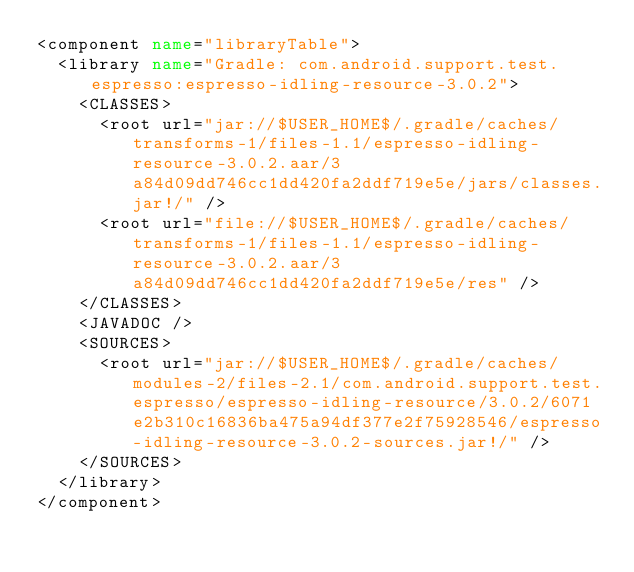Convert code to text. <code><loc_0><loc_0><loc_500><loc_500><_XML_><component name="libraryTable">
  <library name="Gradle: com.android.support.test.espresso:espresso-idling-resource-3.0.2">
    <CLASSES>
      <root url="jar://$USER_HOME$/.gradle/caches/transforms-1/files-1.1/espresso-idling-resource-3.0.2.aar/3a84d09dd746cc1dd420fa2ddf719e5e/jars/classes.jar!/" />
      <root url="file://$USER_HOME$/.gradle/caches/transforms-1/files-1.1/espresso-idling-resource-3.0.2.aar/3a84d09dd746cc1dd420fa2ddf719e5e/res" />
    </CLASSES>
    <JAVADOC />
    <SOURCES>
      <root url="jar://$USER_HOME$/.gradle/caches/modules-2/files-2.1/com.android.support.test.espresso/espresso-idling-resource/3.0.2/6071e2b310c16836ba475a94df377e2f75928546/espresso-idling-resource-3.0.2-sources.jar!/" />
    </SOURCES>
  </library>
</component></code> 